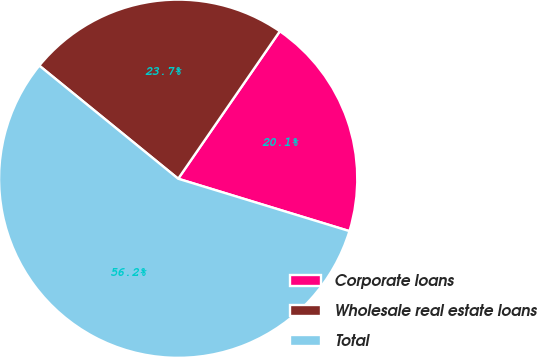Convert chart. <chart><loc_0><loc_0><loc_500><loc_500><pie_chart><fcel>Corporate loans<fcel>Wholesale real estate loans<fcel>Total<nl><fcel>20.12%<fcel>23.73%<fcel>56.15%<nl></chart> 